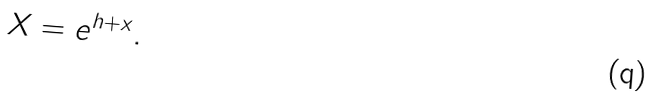<formula> <loc_0><loc_0><loc_500><loc_500>X = e ^ { h + x } .</formula> 